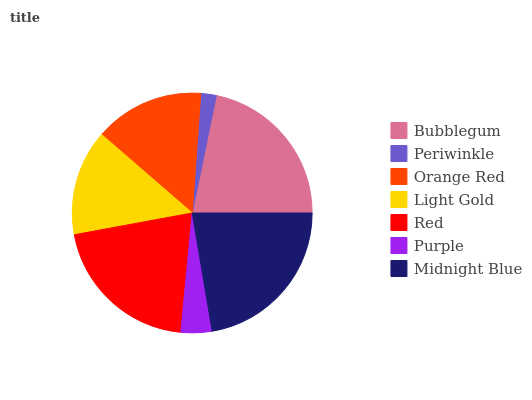Is Periwinkle the minimum?
Answer yes or no. Yes. Is Midnight Blue the maximum?
Answer yes or no. Yes. Is Orange Red the minimum?
Answer yes or no. No. Is Orange Red the maximum?
Answer yes or no. No. Is Orange Red greater than Periwinkle?
Answer yes or no. Yes. Is Periwinkle less than Orange Red?
Answer yes or no. Yes. Is Periwinkle greater than Orange Red?
Answer yes or no. No. Is Orange Red less than Periwinkle?
Answer yes or no. No. Is Orange Red the high median?
Answer yes or no. Yes. Is Orange Red the low median?
Answer yes or no. Yes. Is Red the high median?
Answer yes or no. No. Is Red the low median?
Answer yes or no. No. 